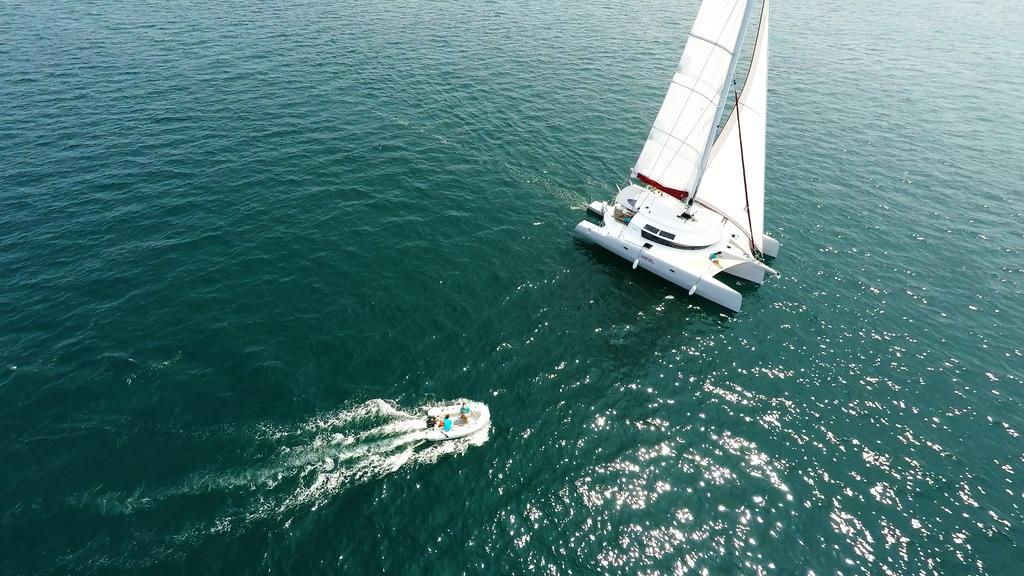What is the primary element visible in the image? There is water in the image. Can you describe the possible location of the water? The water might be in the sea. What activity is taking place in the water? There are men riding a boat in the water. What type of boat are the men riding? The boat is a sailing boat. What is the sailing boat doing in the water? The sailing boat is sailing on the water. What is the price of the girls' finger in the image? There are no girls or fingers present in the image; it features water, a sailing boat, and men riding the boat. 